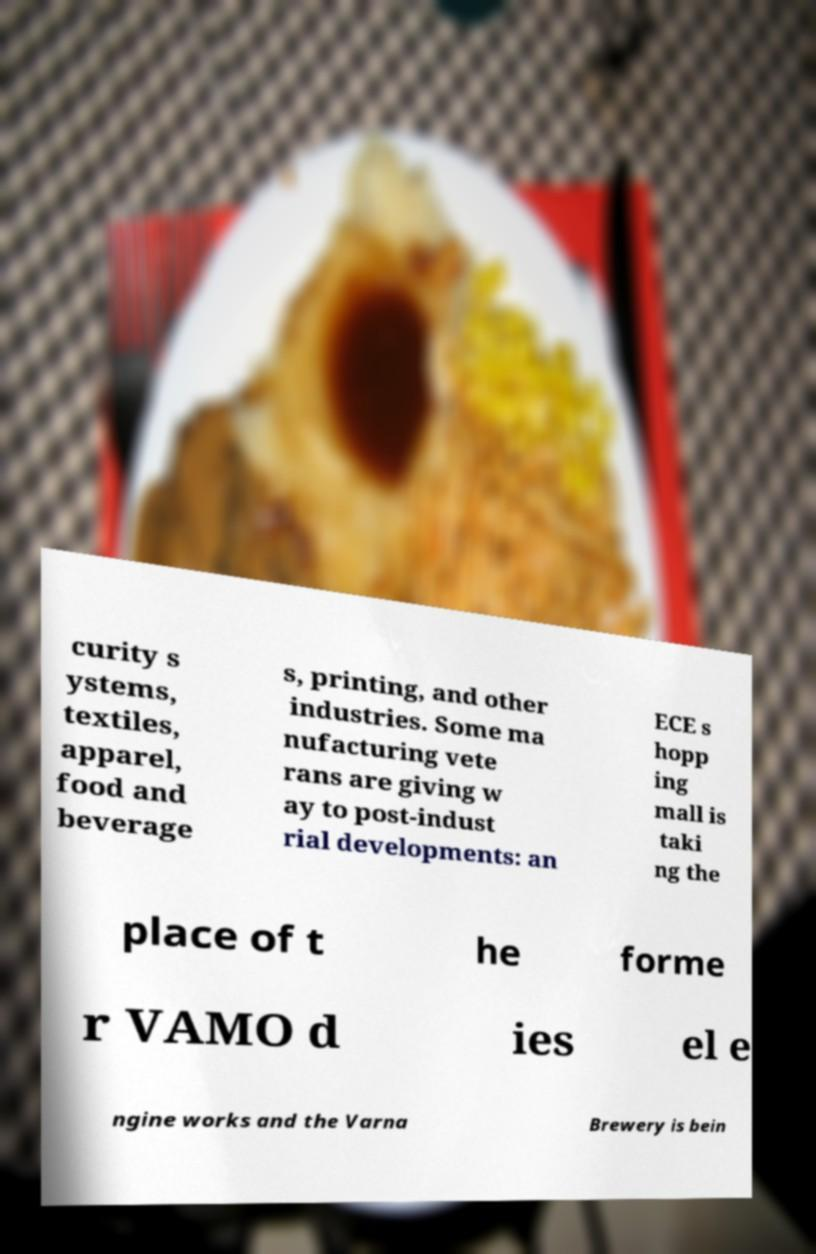There's text embedded in this image that I need extracted. Can you transcribe it verbatim? curity s ystems, textiles, apparel, food and beverage s, printing, and other industries. Some ma nufacturing vete rans are giving w ay to post-indust rial developments: an ECE s hopp ing mall is taki ng the place of t he forme r VAMO d ies el e ngine works and the Varna Brewery is bein 